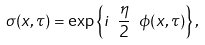<formula> <loc_0><loc_0><loc_500><loc_500>\sigma ( x , \tau ) = \exp \left \{ i \ \frac { \eta } { 2 } \ \phi ( x , \tau ) \right \} ,</formula> 